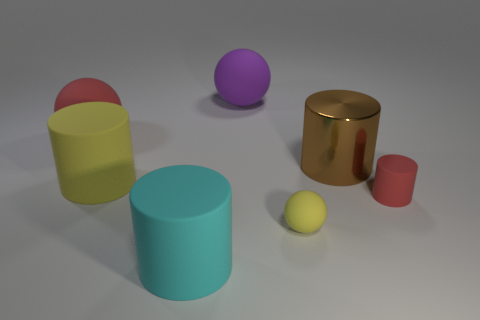Subtract all matte cylinders. How many cylinders are left? 1 Add 3 large matte spheres. How many objects exist? 10 Subtract all brown cylinders. How many cylinders are left? 3 Subtract all cylinders. How many objects are left? 3 Subtract 2 cylinders. How many cylinders are left? 2 Subtract 1 brown cylinders. How many objects are left? 6 Subtract all blue cylinders. Subtract all yellow cubes. How many cylinders are left? 4 Subtract all gray cubes. How many gray cylinders are left? 0 Subtract all matte cylinders. Subtract all cyan objects. How many objects are left? 3 Add 5 large brown objects. How many large brown objects are left? 6 